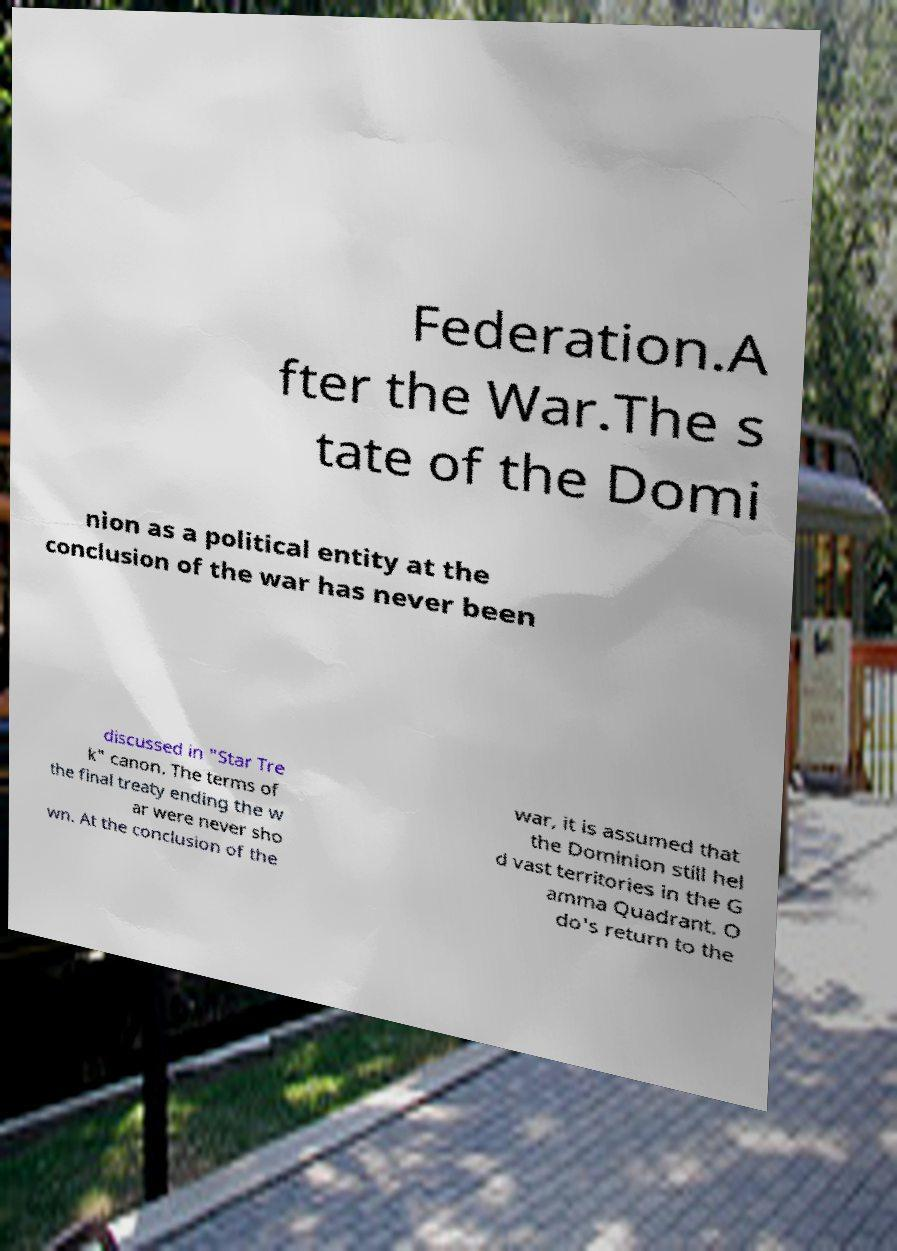Can you accurately transcribe the text from the provided image for me? Federation.A fter the War.The s tate of the Domi nion as a political entity at the conclusion of the war has never been discussed in "Star Tre k" canon. The terms of the final treaty ending the w ar were never sho wn. At the conclusion of the war, it is assumed that the Dominion still hel d vast territories in the G amma Quadrant. O do's return to the 